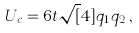Convert formula to latex. <formula><loc_0><loc_0><loc_500><loc_500>U _ { c } = 6 t \sqrt { [ } 4 ] { q _ { 1 } q _ { 2 } } \, ,</formula> 